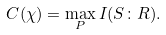<formula> <loc_0><loc_0><loc_500><loc_500>C ( \mathcal { \chi } ) = \max _ { P } I ( S \colon R ) .</formula> 